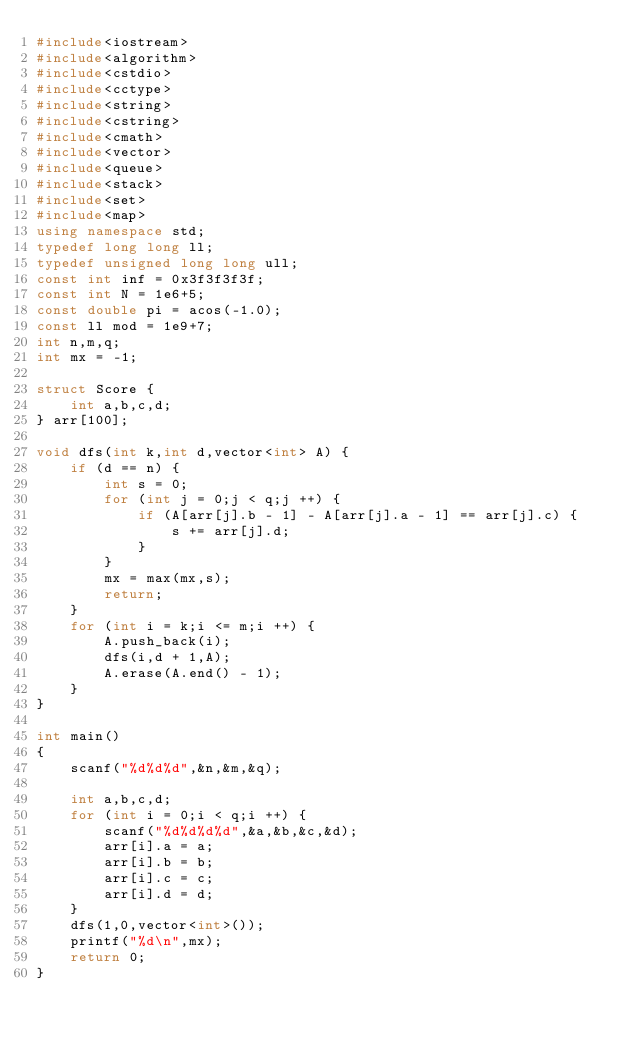<code> <loc_0><loc_0><loc_500><loc_500><_C++_>#include<iostream>
#include<algorithm> 
#include<cstdio>
#include<cctype>
#include<string>
#include<cstring>
#include<cmath>
#include<vector>
#include<queue>
#include<stack>
#include<set>
#include<map>
using namespace std;
typedef long long ll;
typedef unsigned long long ull;
const int inf = 0x3f3f3f3f;
const int N = 1e6+5;
const double pi = acos(-1.0);
const ll mod = 1e9+7;
int n,m,q;
int mx = -1;

struct Score {
    int a,b,c,d;
} arr[100];

void dfs(int k,int d,vector<int> A) {
    if (d == n) {
        int s = 0;
        for (int j = 0;j < q;j ++) {
            if (A[arr[j].b - 1] - A[arr[j].a - 1] == arr[j].c) {
                s += arr[j].d;
            }
        }
        mx = max(mx,s);
        return;
    }
    for (int i = k;i <= m;i ++) {
        A.push_back(i);
        dfs(i,d + 1,A);
        A.erase(A.end() - 1);
    }
}

int main()
{
    scanf("%d%d%d",&n,&m,&q);
    
    int a,b,c,d;
    for (int i = 0;i < q;i ++) {
        scanf("%d%d%d%d",&a,&b,&c,&d);
        arr[i].a = a;
        arr[i].b = b;
        arr[i].c = c;
        arr[i].d = d;
    }
    dfs(1,0,vector<int>());
    printf("%d\n",mx);
    return 0;
}
</code> 